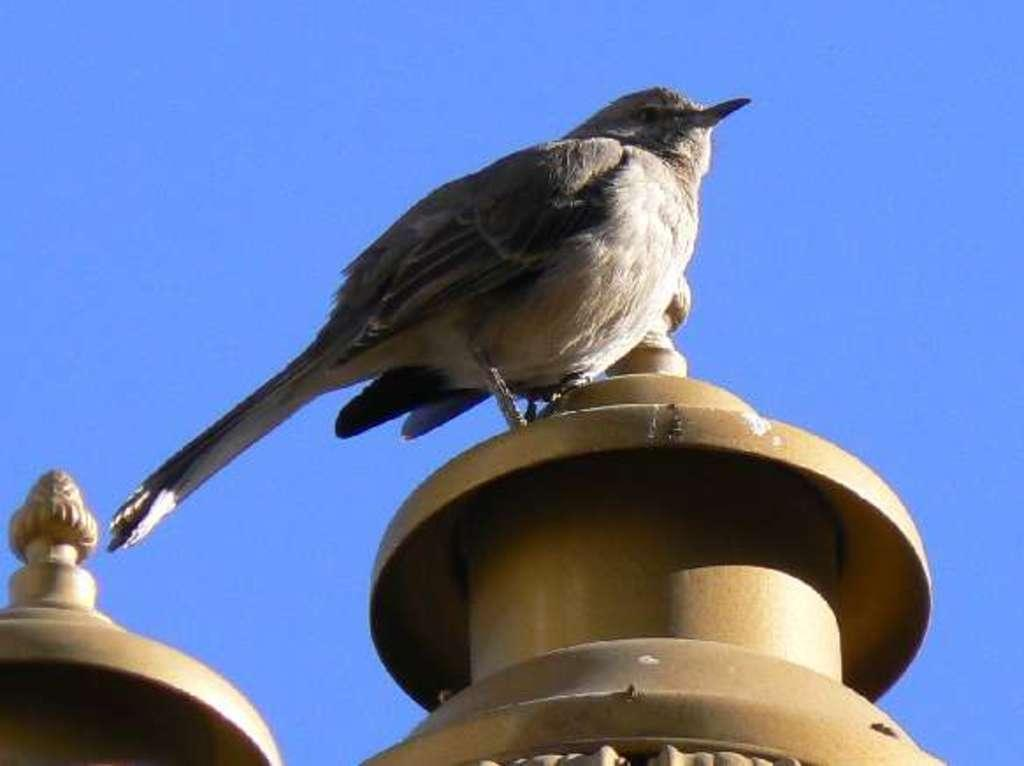What objects are at the bottom of the image? There are poles at the bottom of the image. What is on the poles? A bird is present on the poles. What can be seen behind the bird? The sky is visible behind the bird. What type of ring is the bird wearing on its leg in the image? There is no ring visible on the bird's leg in the image. Is the party happening at night in the image? There is no indication of a party or the time of day in the image. 